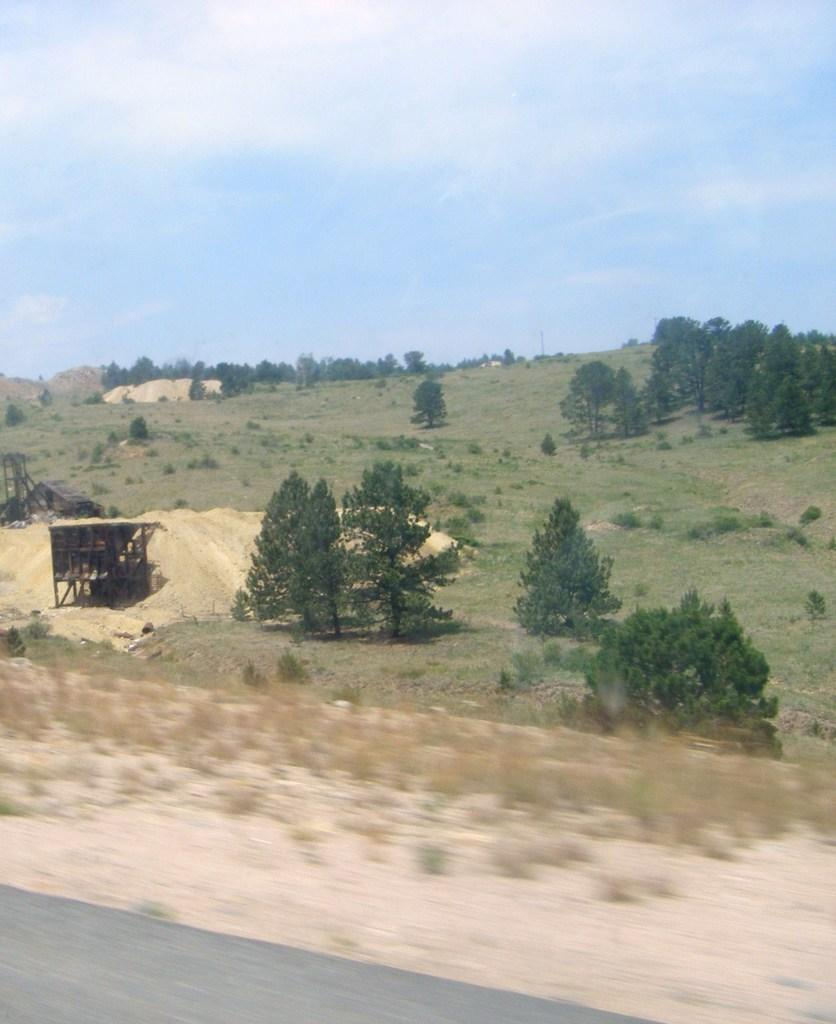What is located at the bottom of the image? There is a walkway, sand, and plants at the bottom of the image. What type of vegetation can be seen at the bottom of the image? There are plants at the bottom of the image. What can be seen in the background of the image? There are trees, grass, plants, and sheds in the background of the image. What is visible at the top of the image? The sky is visible at the top of the image. What is the name of the society depicted in the image? There is no society depicted in the image; it features a walkway, sand, plants, trees, grass, plants, sheds, and the sky. What town is shown in the image? There is no town shown in the image; it features a walkway, sand, plants, trees, grass, plants, sheds, and the sky. 